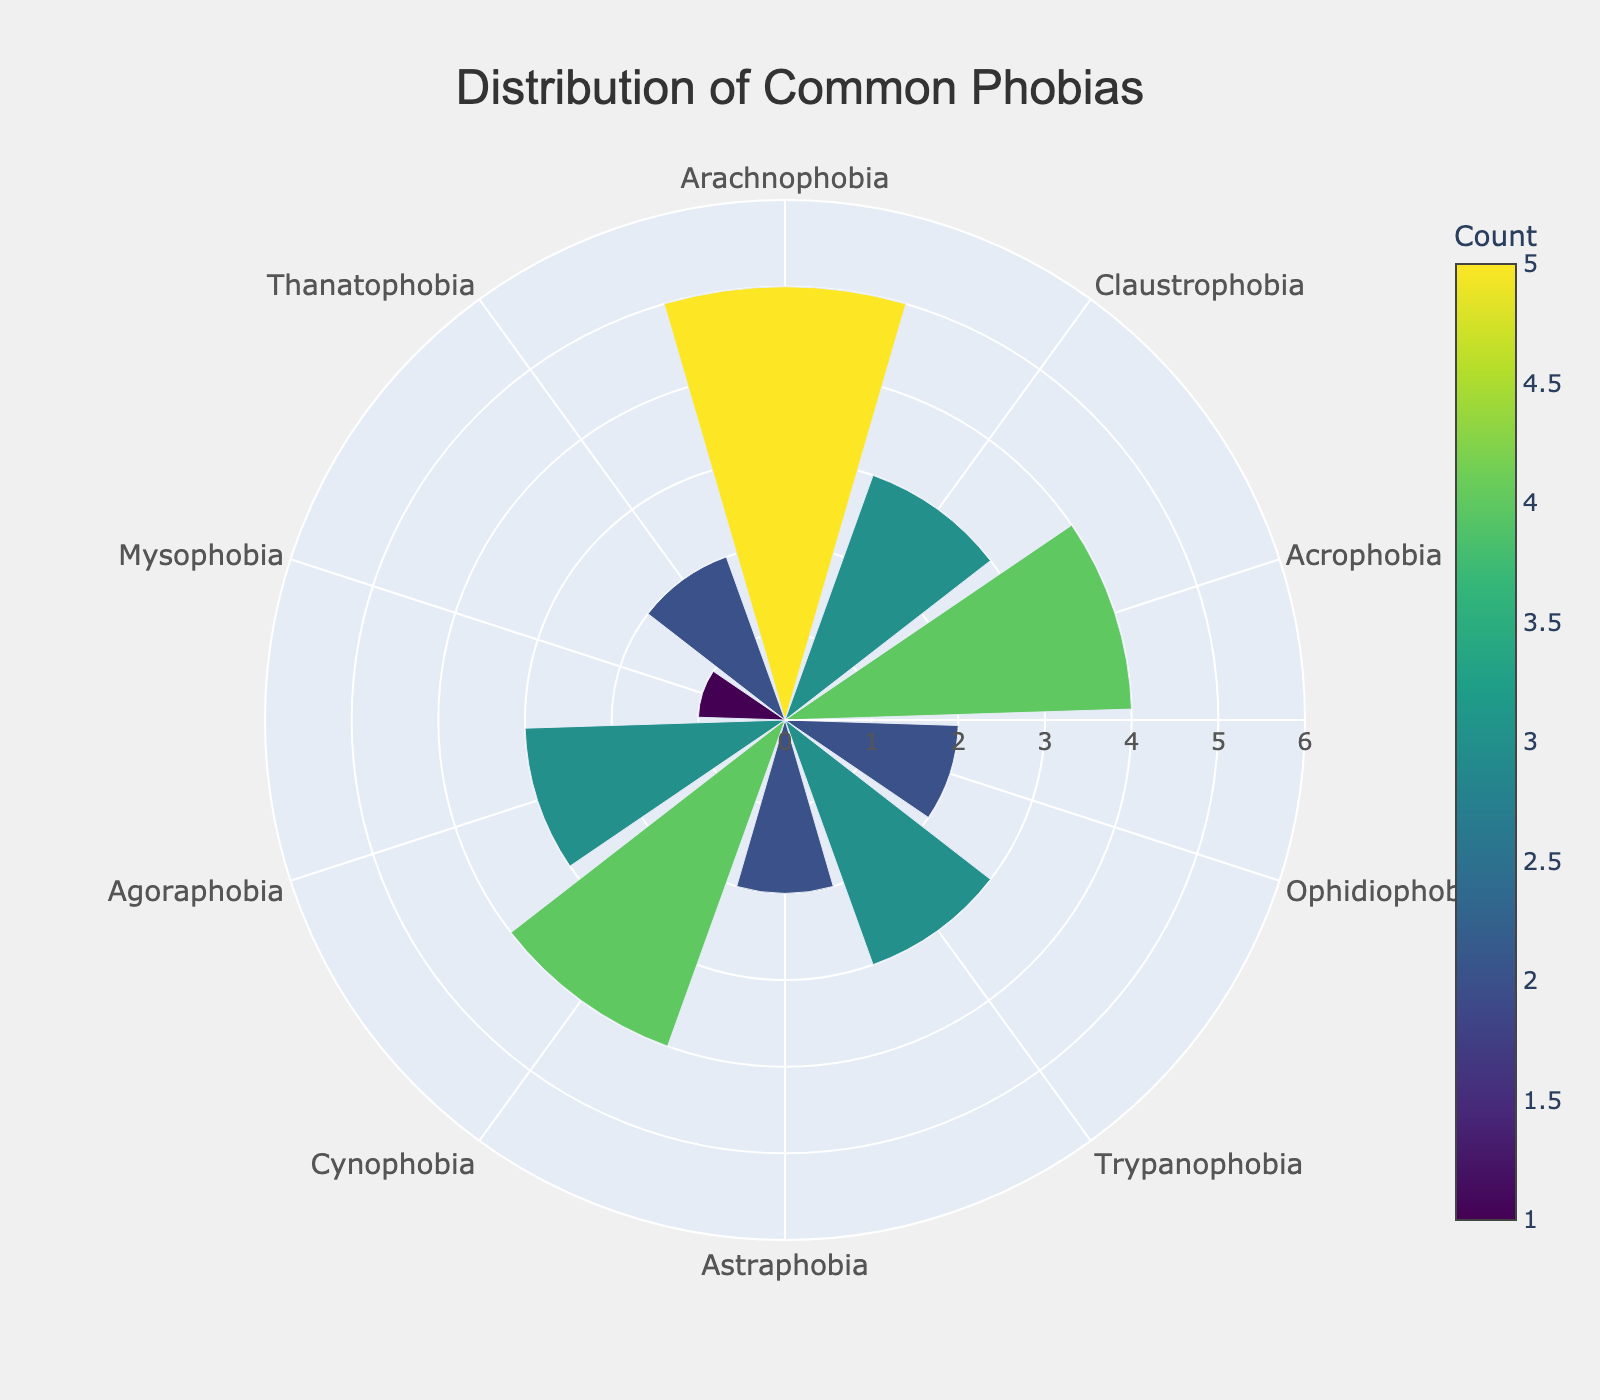Which phobia has the highest count? Arachnophobia is at the top of the list with a count of 5, which is visually represented by the longest bar in the rose chart.
Answer: Arachnophobia How many phobias have a count of 2? By looking at the lengths of the bars with a value of 2, there are four phobias: Ophidiophobia, Astraphobia, Mysophobia, and Thanatophobia.
Answer: 4 What is the average count of the phobias? Adding the counts for all phobias (5 + 3 + 4 + 2 + 3 + 2 + 4 + 3 + 1 + 2) equals 29. Dividing by the number of phobias (10) gives 29 / 10 = 2.9.
Answer: 2.9 Which phobia has the shortest bar in the rose chart? The shortest bar, representing the lowest count of 1, belongs to Mysophobia.
Answer: Mysophobia Is the count of Acrophobia greater than Claustrophobia? The count for Acrophobia is 4, while Claustrophobia has a count of 3, making Acrophobia greater than Claustrophobia.
Answer: Yes How many phobias have a count of more than 3? The phobias with counts greater than 3 are Arachnophobia, Acrophobia, and Cynophobia, totaling three phobias.
Answer: 3 What's the difference in counts between Cynophobia and Trypanophobia? Cynophobia has a count of 4, and Trypanophobia has a count of 3. The difference is 4 - 3 = 1.
Answer: 1 Which two phobias have equal counts of 3? By examining the figure, Claustrophobia, Trypanophobia, and Agoraphobia all have a count of 3.
Answer: Claustrophobia, Trypanophobia, Agoraphobia Is the count for Arachnophobia greater than twice the count for Thanatophobia? The count for Arachnophobia is 5, and twice the count for Thanatophobia is 2 * 2 = 4. Since 5 > 4, the count for Arachnophobia is indeed greater.
Answer: Yes 